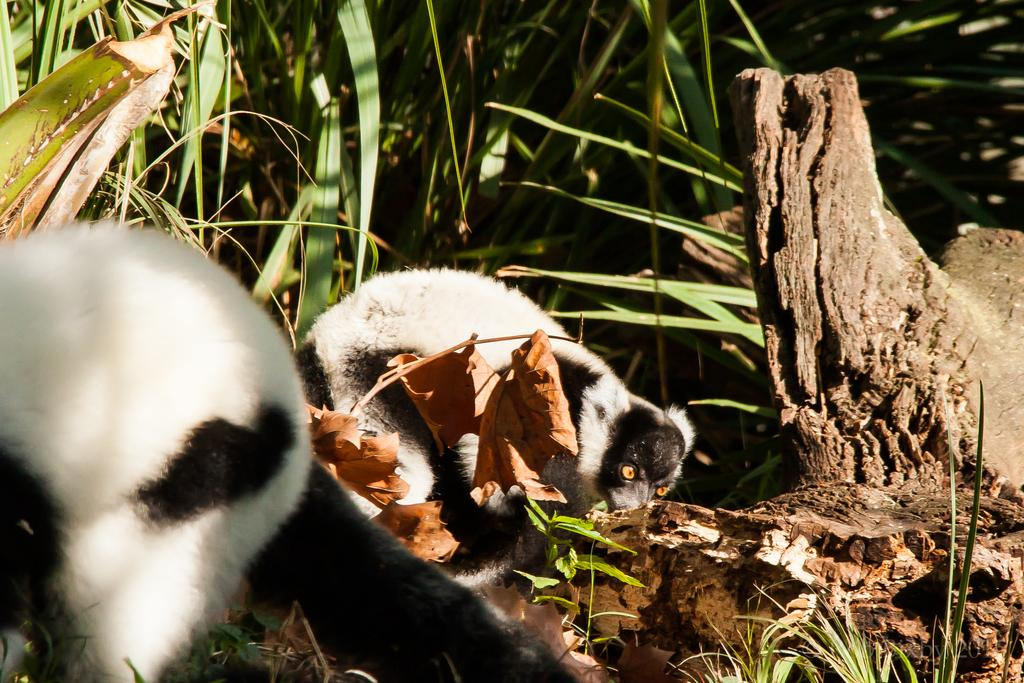What types of living organisms can be seen on the ground in the image? There are animals on the ground in the image. What other natural elements are present in the image? There are plants and a tree trunk in the image. How many airplanes are visible in the image? There are no airplanes present in the image. What type of fold can be seen in the tree trunk in the image? There is no fold present in the tree trunk in the image; it is a solid, unbroken structure. 